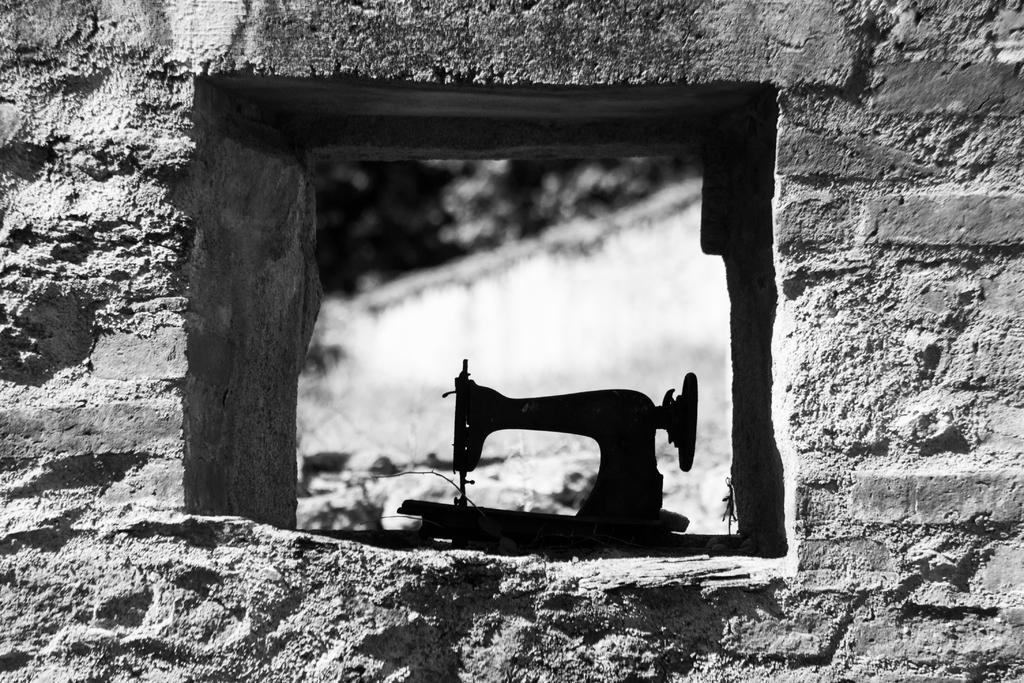What is one of the main objects in the image? There is a sewing machine in the image. What can be seen in the background of the image? The background of the image is blurry. Can you describe the setting of the image? The presence of a sewing machine suggests that the image might be in a workspace or home setting. What type of pancake is being served at the cemetery in the image? There is no cemetery or pancake present in the image; it features a sewing machine and a blurry background. 